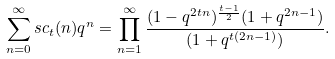<formula> <loc_0><loc_0><loc_500><loc_500>\sum _ { n = 0 } ^ { \infty } s c _ { t } ( n ) q ^ { n } = \prod _ { n = 1 } ^ { \infty } \frac { ( 1 - q ^ { 2 t n } ) ^ { \frac { t - 1 } { 2 } } ( 1 + q ^ { 2 n - 1 } ) } { ( 1 + q ^ { t ( 2 n - 1 ) } ) } .</formula> 